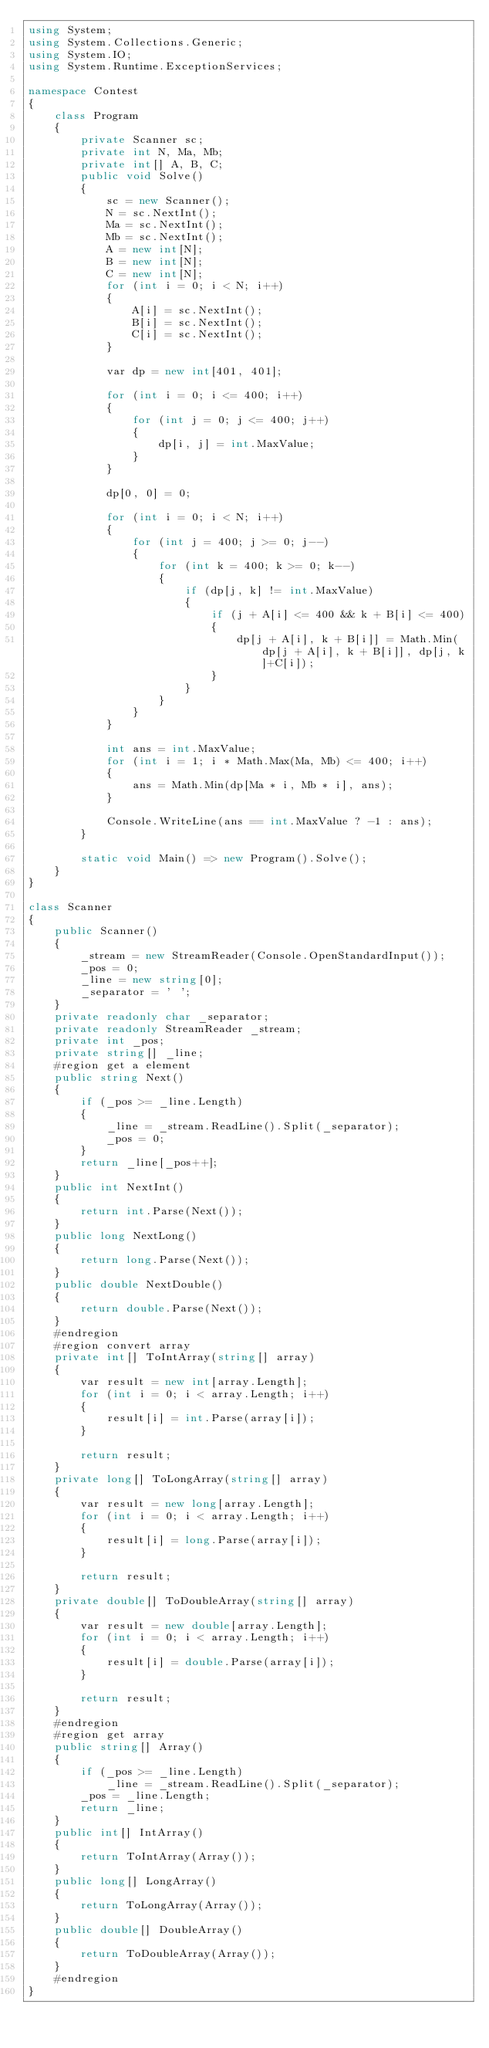<code> <loc_0><loc_0><loc_500><loc_500><_C#_>using System;
using System.Collections.Generic;
using System.IO;
using System.Runtime.ExceptionServices;

namespace Contest
{
    class Program
    {
        private Scanner sc;
        private int N, Ma, Mb;
        private int[] A, B, C;
        public void Solve()
        {
            sc = new Scanner();
            N = sc.NextInt();
            Ma = sc.NextInt();
            Mb = sc.NextInt();
            A = new int[N];
            B = new int[N];
            C = new int[N];
            for (int i = 0; i < N; i++)
            {
                A[i] = sc.NextInt();
                B[i] = sc.NextInt();
                C[i] = sc.NextInt();
            }

            var dp = new int[401, 401];

            for (int i = 0; i <= 400; i++)
            {
                for (int j = 0; j <= 400; j++)
                {
                    dp[i, j] = int.MaxValue;
                }
            }

            dp[0, 0] = 0;

            for (int i = 0; i < N; i++)
            {
                for (int j = 400; j >= 0; j--)
                {
                    for (int k = 400; k >= 0; k--)
                    {
                        if (dp[j, k] != int.MaxValue)
                        {
                            if (j + A[i] <= 400 && k + B[i] <= 400)
                            {
                                dp[j + A[i], k + B[i]] = Math.Min(dp[j + A[i], k + B[i]], dp[j, k]+C[i]);
                            }
                        }
                    }
                }
            }

            int ans = int.MaxValue;
            for (int i = 1; i * Math.Max(Ma, Mb) <= 400; i++)
            {
                ans = Math.Min(dp[Ma * i, Mb * i], ans);
            }

            Console.WriteLine(ans == int.MaxValue ? -1 : ans);
        }

        static void Main() => new Program().Solve();
    }
}

class Scanner
{
    public Scanner()
    {
        _stream = new StreamReader(Console.OpenStandardInput());
        _pos = 0;
        _line = new string[0];
        _separator = ' ';
    }
    private readonly char _separator;
    private readonly StreamReader _stream;
    private int _pos;
    private string[] _line;
    #region get a element
    public string Next()
    {
        if (_pos >= _line.Length)
        {
            _line = _stream.ReadLine().Split(_separator);
            _pos = 0;
        }
        return _line[_pos++];
    }
    public int NextInt()
    {
        return int.Parse(Next());
    }
    public long NextLong()
    {
        return long.Parse(Next());
    }
    public double NextDouble()
    {
        return double.Parse(Next());
    }
    #endregion
    #region convert array
    private int[] ToIntArray(string[] array)
    {
        var result = new int[array.Length];
        for (int i = 0; i < array.Length; i++)
        {
            result[i] = int.Parse(array[i]);
        }

        return result;
    }
    private long[] ToLongArray(string[] array)
    {
        var result = new long[array.Length];
        for (int i = 0; i < array.Length; i++)
        {
            result[i] = long.Parse(array[i]);
        }

        return result;
    }
    private double[] ToDoubleArray(string[] array)
    {
        var result = new double[array.Length];
        for (int i = 0; i < array.Length; i++)
        {
            result[i] = double.Parse(array[i]);
        }

        return result;
    }
    #endregion
    #region get array
    public string[] Array()
    {
        if (_pos >= _line.Length)
            _line = _stream.ReadLine().Split(_separator);
        _pos = _line.Length;
        return _line;
    }
    public int[] IntArray()
    {
        return ToIntArray(Array());
    }
    public long[] LongArray()
    {
        return ToLongArray(Array());
    }
    public double[] DoubleArray()
    {
        return ToDoubleArray(Array());
    }
    #endregion
}</code> 